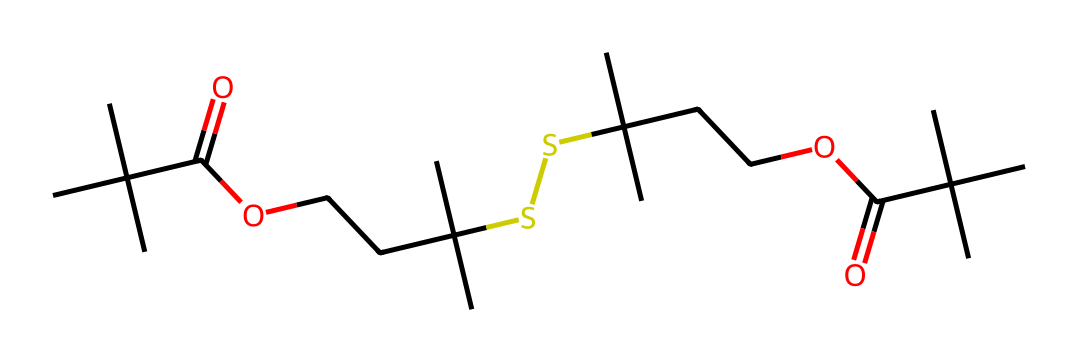What is the backbone of this organosulfur compound? The primary structure of the compound shows a carbon-based backbone as indicated by the continuous chain of carbon atoms, interspersed with a sulfur atom in its structure.
Answer: carbon How many sulfur atoms are present in the structure? By analyzing the SMILES notation, "S" appears only twice, indicating that there are two sulfur atoms in the compound.
Answer: two What type of polymer does this organosulfur compound represent? Given the presence of sulfur within the structure and its long-chain configuration, it is categorized as a sulfur-containing polymer, essential for high-performance applications in seals and gaskets.
Answer: sulfur-containing polymer What is the total count of carbon atoms in this chemical structure? Counting all the carbon atoms represented by "C" in the SMILES string reveals there are 20 carbon atoms present.
Answer: 20 Which functional group is primarily responsible for the potential for high-performance in seals? The carboxylic acid groups (C(=O)O) and their positioning along the carbon chains contribute significantly to the material's performance characteristics in applications like gaskets.
Answer: carboxylic acid What distinctive feature in organosulfur compounds enhances their thermal stability? The presence of sulfur atoms within the polymer chain helps improve thermal stability by forming stronger molecular interactions, which is critical for high-performance materials.
Answer: sulfur 